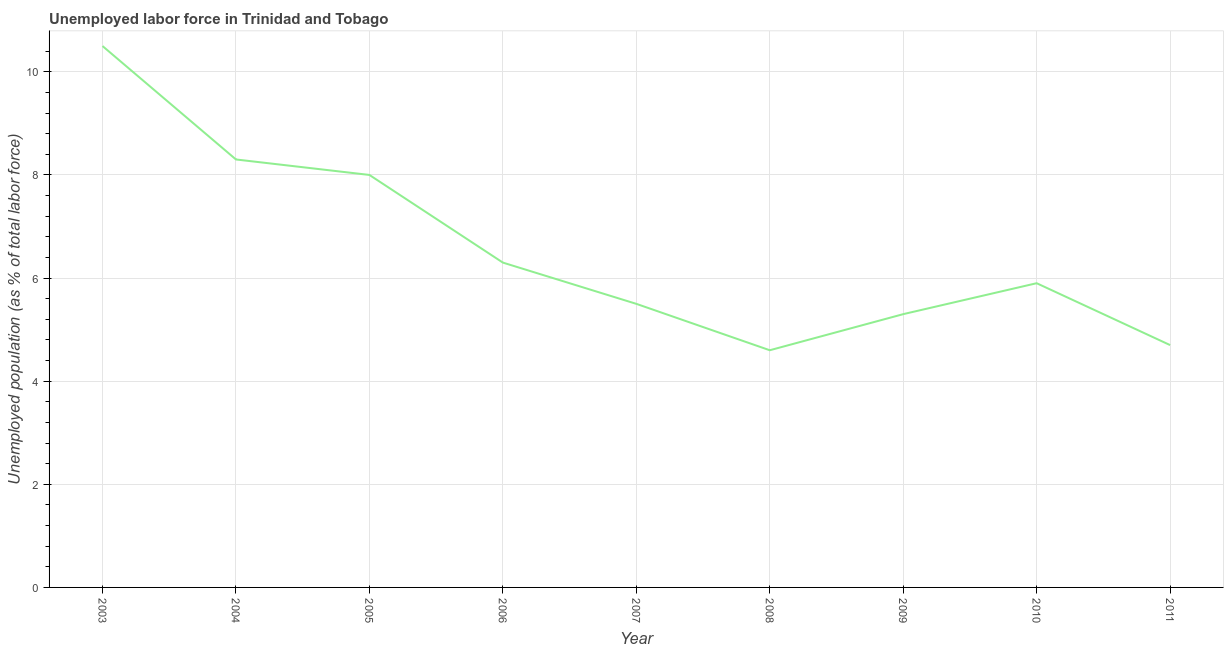What is the total unemployed population in 2009?
Your answer should be compact. 5.3. Across all years, what is the minimum total unemployed population?
Make the answer very short. 4.6. In which year was the total unemployed population maximum?
Provide a short and direct response. 2003. In which year was the total unemployed population minimum?
Provide a short and direct response. 2008. What is the sum of the total unemployed population?
Ensure brevity in your answer.  59.1. What is the difference between the total unemployed population in 2007 and 2010?
Provide a short and direct response. -0.4. What is the average total unemployed population per year?
Provide a succinct answer. 6.57. What is the median total unemployed population?
Your answer should be compact. 5.9. Do a majority of the years between 2011 and 2007 (inclusive) have total unemployed population greater than 1.6 %?
Your answer should be compact. Yes. What is the ratio of the total unemployed population in 2005 to that in 2010?
Your answer should be compact. 1.36. Is the total unemployed population in 2007 less than that in 2008?
Provide a succinct answer. No. What is the difference between the highest and the second highest total unemployed population?
Provide a succinct answer. 2.2. Is the sum of the total unemployed population in 2005 and 2006 greater than the maximum total unemployed population across all years?
Keep it short and to the point. Yes. What is the difference between the highest and the lowest total unemployed population?
Ensure brevity in your answer.  5.9. In how many years, is the total unemployed population greater than the average total unemployed population taken over all years?
Provide a succinct answer. 3. How many lines are there?
Your answer should be compact. 1. What is the difference between two consecutive major ticks on the Y-axis?
Give a very brief answer. 2. Are the values on the major ticks of Y-axis written in scientific E-notation?
Provide a succinct answer. No. Does the graph contain grids?
Ensure brevity in your answer.  Yes. What is the title of the graph?
Offer a terse response. Unemployed labor force in Trinidad and Tobago. What is the label or title of the X-axis?
Offer a very short reply. Year. What is the label or title of the Y-axis?
Give a very brief answer. Unemployed population (as % of total labor force). What is the Unemployed population (as % of total labor force) in 2003?
Your answer should be very brief. 10.5. What is the Unemployed population (as % of total labor force) of 2004?
Ensure brevity in your answer.  8.3. What is the Unemployed population (as % of total labor force) of 2005?
Make the answer very short. 8. What is the Unemployed population (as % of total labor force) in 2006?
Make the answer very short. 6.3. What is the Unemployed population (as % of total labor force) in 2007?
Your answer should be compact. 5.5. What is the Unemployed population (as % of total labor force) in 2008?
Ensure brevity in your answer.  4.6. What is the Unemployed population (as % of total labor force) in 2009?
Offer a terse response. 5.3. What is the Unemployed population (as % of total labor force) of 2010?
Keep it short and to the point. 5.9. What is the Unemployed population (as % of total labor force) in 2011?
Offer a terse response. 4.7. What is the difference between the Unemployed population (as % of total labor force) in 2003 and 2004?
Ensure brevity in your answer.  2.2. What is the difference between the Unemployed population (as % of total labor force) in 2003 and 2007?
Give a very brief answer. 5. What is the difference between the Unemployed population (as % of total labor force) in 2003 and 2011?
Provide a succinct answer. 5.8. What is the difference between the Unemployed population (as % of total labor force) in 2004 and 2005?
Ensure brevity in your answer.  0.3. What is the difference between the Unemployed population (as % of total labor force) in 2004 and 2008?
Your answer should be very brief. 3.7. What is the difference between the Unemployed population (as % of total labor force) in 2004 and 2009?
Provide a succinct answer. 3. What is the difference between the Unemployed population (as % of total labor force) in 2004 and 2010?
Your response must be concise. 2.4. What is the difference between the Unemployed population (as % of total labor force) in 2004 and 2011?
Your response must be concise. 3.6. What is the difference between the Unemployed population (as % of total labor force) in 2005 and 2006?
Provide a succinct answer. 1.7. What is the difference between the Unemployed population (as % of total labor force) in 2005 and 2007?
Ensure brevity in your answer.  2.5. What is the difference between the Unemployed population (as % of total labor force) in 2005 and 2010?
Give a very brief answer. 2.1. What is the difference between the Unemployed population (as % of total labor force) in 2006 and 2007?
Provide a succinct answer. 0.8. What is the difference between the Unemployed population (as % of total labor force) in 2006 and 2008?
Keep it short and to the point. 1.7. What is the difference between the Unemployed population (as % of total labor force) in 2007 and 2008?
Make the answer very short. 0.9. What is the difference between the Unemployed population (as % of total labor force) in 2007 and 2010?
Make the answer very short. -0.4. What is the difference between the Unemployed population (as % of total labor force) in 2008 and 2009?
Your response must be concise. -0.7. What is the difference between the Unemployed population (as % of total labor force) in 2008 and 2011?
Give a very brief answer. -0.1. What is the difference between the Unemployed population (as % of total labor force) in 2009 and 2010?
Your answer should be very brief. -0.6. What is the difference between the Unemployed population (as % of total labor force) in 2009 and 2011?
Offer a very short reply. 0.6. What is the ratio of the Unemployed population (as % of total labor force) in 2003 to that in 2004?
Offer a terse response. 1.26. What is the ratio of the Unemployed population (as % of total labor force) in 2003 to that in 2005?
Offer a very short reply. 1.31. What is the ratio of the Unemployed population (as % of total labor force) in 2003 to that in 2006?
Provide a succinct answer. 1.67. What is the ratio of the Unemployed population (as % of total labor force) in 2003 to that in 2007?
Keep it short and to the point. 1.91. What is the ratio of the Unemployed population (as % of total labor force) in 2003 to that in 2008?
Ensure brevity in your answer.  2.28. What is the ratio of the Unemployed population (as % of total labor force) in 2003 to that in 2009?
Keep it short and to the point. 1.98. What is the ratio of the Unemployed population (as % of total labor force) in 2003 to that in 2010?
Ensure brevity in your answer.  1.78. What is the ratio of the Unemployed population (as % of total labor force) in 2003 to that in 2011?
Your response must be concise. 2.23. What is the ratio of the Unemployed population (as % of total labor force) in 2004 to that in 2005?
Offer a very short reply. 1.04. What is the ratio of the Unemployed population (as % of total labor force) in 2004 to that in 2006?
Provide a short and direct response. 1.32. What is the ratio of the Unemployed population (as % of total labor force) in 2004 to that in 2007?
Your answer should be very brief. 1.51. What is the ratio of the Unemployed population (as % of total labor force) in 2004 to that in 2008?
Your answer should be compact. 1.8. What is the ratio of the Unemployed population (as % of total labor force) in 2004 to that in 2009?
Make the answer very short. 1.57. What is the ratio of the Unemployed population (as % of total labor force) in 2004 to that in 2010?
Offer a very short reply. 1.41. What is the ratio of the Unemployed population (as % of total labor force) in 2004 to that in 2011?
Give a very brief answer. 1.77. What is the ratio of the Unemployed population (as % of total labor force) in 2005 to that in 2006?
Ensure brevity in your answer.  1.27. What is the ratio of the Unemployed population (as % of total labor force) in 2005 to that in 2007?
Your answer should be very brief. 1.46. What is the ratio of the Unemployed population (as % of total labor force) in 2005 to that in 2008?
Offer a very short reply. 1.74. What is the ratio of the Unemployed population (as % of total labor force) in 2005 to that in 2009?
Your answer should be very brief. 1.51. What is the ratio of the Unemployed population (as % of total labor force) in 2005 to that in 2010?
Your response must be concise. 1.36. What is the ratio of the Unemployed population (as % of total labor force) in 2005 to that in 2011?
Ensure brevity in your answer.  1.7. What is the ratio of the Unemployed population (as % of total labor force) in 2006 to that in 2007?
Ensure brevity in your answer.  1.15. What is the ratio of the Unemployed population (as % of total labor force) in 2006 to that in 2008?
Ensure brevity in your answer.  1.37. What is the ratio of the Unemployed population (as % of total labor force) in 2006 to that in 2009?
Offer a terse response. 1.19. What is the ratio of the Unemployed population (as % of total labor force) in 2006 to that in 2010?
Your response must be concise. 1.07. What is the ratio of the Unemployed population (as % of total labor force) in 2006 to that in 2011?
Provide a succinct answer. 1.34. What is the ratio of the Unemployed population (as % of total labor force) in 2007 to that in 2008?
Provide a short and direct response. 1.2. What is the ratio of the Unemployed population (as % of total labor force) in 2007 to that in 2009?
Your answer should be very brief. 1.04. What is the ratio of the Unemployed population (as % of total labor force) in 2007 to that in 2010?
Provide a succinct answer. 0.93. What is the ratio of the Unemployed population (as % of total labor force) in 2007 to that in 2011?
Keep it short and to the point. 1.17. What is the ratio of the Unemployed population (as % of total labor force) in 2008 to that in 2009?
Your answer should be very brief. 0.87. What is the ratio of the Unemployed population (as % of total labor force) in 2008 to that in 2010?
Offer a terse response. 0.78. What is the ratio of the Unemployed population (as % of total labor force) in 2008 to that in 2011?
Keep it short and to the point. 0.98. What is the ratio of the Unemployed population (as % of total labor force) in 2009 to that in 2010?
Ensure brevity in your answer.  0.9. What is the ratio of the Unemployed population (as % of total labor force) in 2009 to that in 2011?
Your answer should be compact. 1.13. What is the ratio of the Unemployed population (as % of total labor force) in 2010 to that in 2011?
Keep it short and to the point. 1.25. 